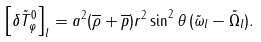Convert formula to latex. <formula><loc_0><loc_0><loc_500><loc_500>\left [ \delta \tilde { T } _ { \varphi } ^ { 0 } \right ] _ { l } = a ^ { 2 } ( \overline { \rho } + \overline { p } ) r ^ { 2 } \sin ^ { 2 } \theta \, ( \tilde { \omega } _ { l } - \tilde { \Omega } _ { l } ) .</formula> 